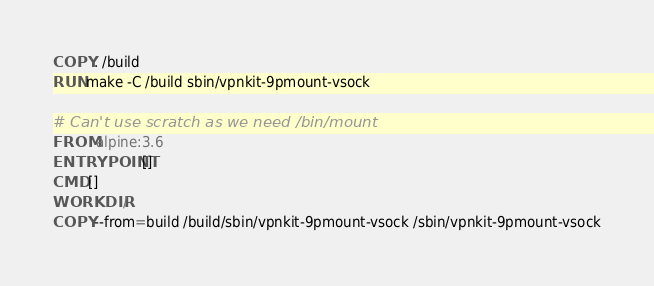Convert code to text. <code><loc_0><loc_0><loc_500><loc_500><_Dockerfile_>COPY . /build
RUN make -C /build sbin/vpnkit-9pmount-vsock

# Can't use scratch as we need /bin/mount
FROM alpine:3.6
ENTRYPOINT []
CMD []
WORKDIR /
COPY --from=build /build/sbin/vpnkit-9pmount-vsock /sbin/vpnkit-9pmount-vsock
</code> 